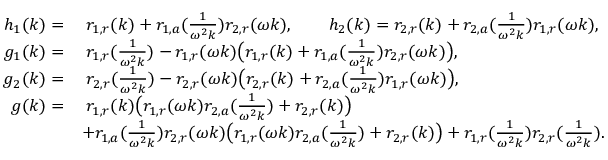<formula> <loc_0><loc_0><loc_500><loc_500>\begin{array} { r l } { h _ { 1 } ( k ) = } & { \, r _ { 1 , r } ( k ) + r _ { 1 , a } ( \frac { 1 } { \omega ^ { 2 } k } ) r _ { 2 , r } ( \omega k ) , \quad h _ { 2 } ( k ) = r _ { 2 , r } ( k ) + r _ { 2 , a } ( \frac { 1 } { \omega ^ { 2 } k } ) r _ { 1 , r } ( \omega k ) , } \\ { g _ { 1 } ( k ) = } & { \, r _ { 1 , r } ( \frac { 1 } { \omega ^ { 2 } k } ) - r _ { 1 , r } ( \omega k ) \left ( r _ { 1 , r } ( k ) + r _ { 1 , a } ( \frac { 1 } { \omega ^ { 2 } k } ) r _ { 2 , r } ( \omega k ) \right ) , } \\ { g _ { 2 } ( k ) = } & { \, r _ { 2 , r } ( \frac { 1 } { \omega ^ { 2 } k } ) - r _ { 2 , r } ( \omega k ) \left ( r _ { 2 , r } ( k ) + r _ { 2 , a } ( \frac { 1 } { \omega ^ { 2 } k } ) r _ { 1 , r } ( \omega k ) \right ) , } \\ { g ( k ) = } & { \, r _ { 1 , r } ( k ) \left ( r _ { 1 , r } ( \omega k ) r _ { 2 , a } ( \frac { 1 } { \omega ^ { 2 } k } ) + r _ { 2 , r } ( k ) \right ) } \\ & { + r _ { 1 , a } ( \frac { 1 } { \omega ^ { 2 } k } ) r _ { 2 , r } ( \omega k ) \left ( r _ { 1 , r } ( \omega k ) r _ { 2 , a } ( \frac { 1 } { \omega ^ { 2 } k } ) + r _ { 2 , r } ( k ) \right ) + r _ { 1 , r } ( \frac { 1 } { \omega ^ { 2 } k } ) r _ { 2 , r } ( \frac { 1 } { \omega ^ { 2 } k } ) . } \end{array}</formula> 